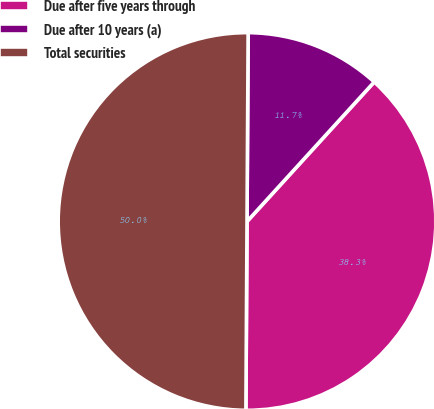Convert chart to OTSL. <chart><loc_0><loc_0><loc_500><loc_500><pie_chart><fcel>Due after five years through<fcel>Due after 10 years (a)<fcel>Total securities<nl><fcel>38.33%<fcel>11.67%<fcel>50.0%<nl></chart> 